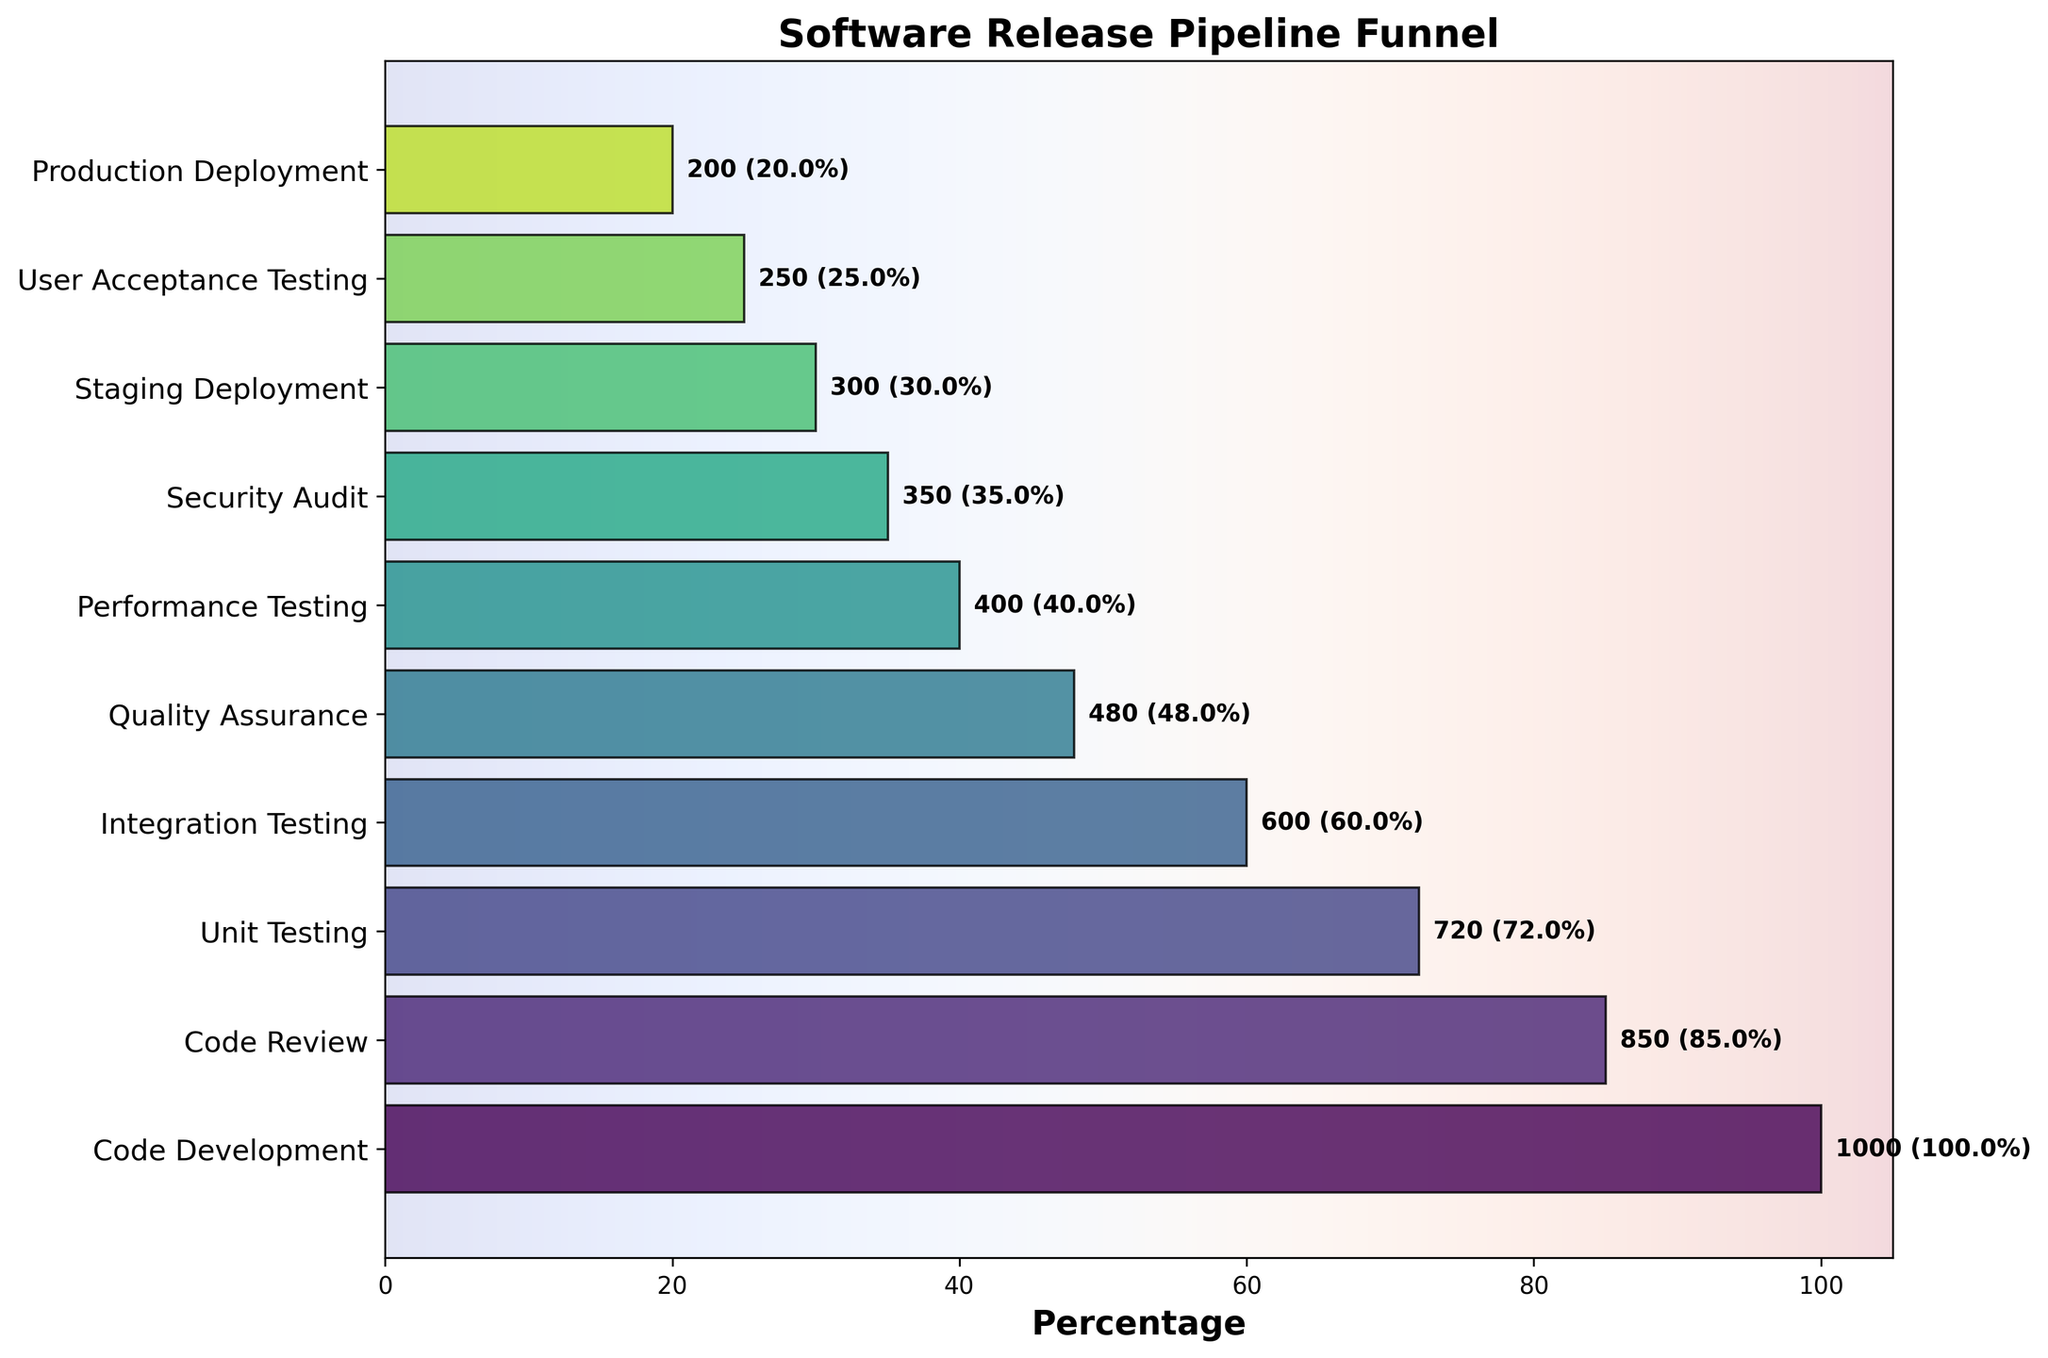How many stages are depicted in the funnel chart? The funnel chart has stages listed on the y-axis, where each tick represents a different stage. By counting the number of stages listed, we can determine the total number of stages.
Answer: 10 What is the percentage of the starting stage in comparison to itself? The starting stage is "Code Development" with 1000 counts. Any stage compared to itself would be 100%, as it's the reference point.
Answer: 100% Which stage has the lowest count? By examining the counts listed next to each stage, we can see the lowest count is at the "Production Deployment" stage with 200 counts.
Answer: Production Deployment What is the difference in counts between "Code Review" and "User Acceptance Testing"? The count for "Code Review" is 850, and for "User Acceptance Testing" it is 250. The difference is calculated by subtracting the latter from the former (850 - 250).
Answer: 600 Which stage has the highest drop in counts compared to the previous stage? By comparing the counts between successive stages, the highest drop is between "Code Development" (1000) and "Code Review" (850), with a drop of 150.
Answer: Code Development to Code Review What is the percentage decrease from "Code Development" to "Production Deployment"? The initial stage "Code Development" starts with 1000 counts and the final stage "Production Deployment" ends with 200 counts. The percentage decrease is calculated as: \( \left( \frac{{1000 - 200}}{1000} \right) \times 100 \).
Answer: 80% Which stage immediately precedes "Security Audit"? By looking at the y-axis, the stage before "Security Audit" is "Performance Testing".
Answer: Performance Testing What is the total number of counts from "Quality Assurance" to "Production Deployment"? Summing the counts from the stages "Quality Assurance" (480), "Performance Testing" (400), "Security Audit" (350), "Staging Deployment" (300), "User Acceptance Testing" (250), and "Production Deployment" (200) gives the total: \(480 + 400 + 350 + 300 + 250 + 200\).
Answer: 1980 Which stage is exactly in the middle of the pipeline? There are 10 stages in total. The middle stage is the 5th stage when counting from the start: "Quality Assurance".
Answer: Quality Assurance 